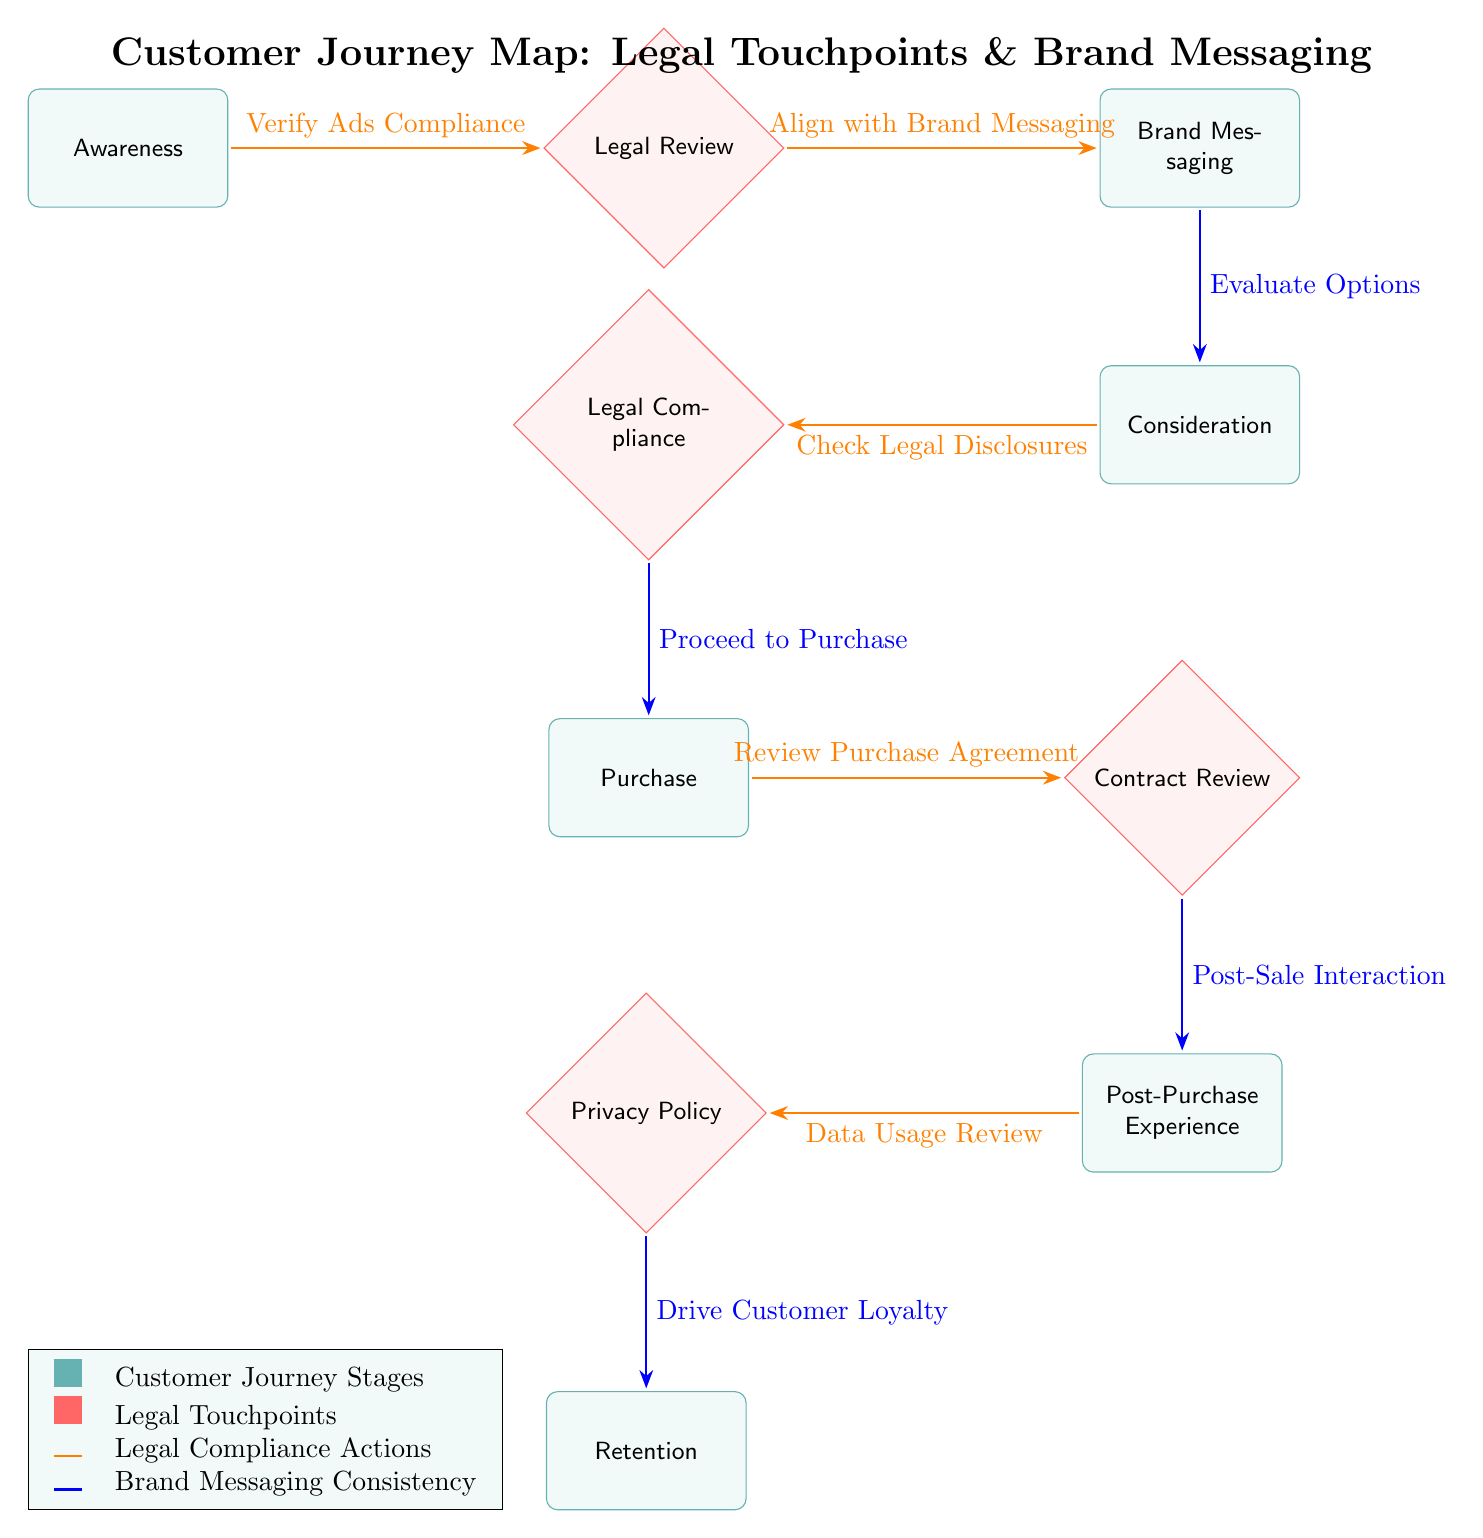What are the stages of the customer journey represented in the diagram? The diagram contains multiple nodes categorized as customer journey stages, including Awareness, Consideration, Purchase, Post-Purchase Experience, and Retention.
Answer: Awareness, Consideration, Purchase, Post-Purchase Experience, Retention How many legal touchpoints are indicated in the diagram? The diagram visually identifies three legal touchpoints represented by diamond-shaped nodes: Legal Review, Legal Compliance, and Contract Review, plus one additional node for Privacy Policy, totaling four legal touchpoints.
Answer: Four What action is associated with proceeding from the Purchase stage? The edge leading from the Purchase stage to the Contract Review legal touchpoint specifies the action "Review Purchase Agreement," highlighting the legal compliance necessary at this stage.
Answer: Review Purchase Agreement Which stage comes immediately after the Consideration stage? According to the flow of the diagram, the stage that follows Consideration is Purchase, which indicates the movement from evaluating options to actually making a purchase.
Answer: Purchase What is the legal action taken after the Post-Purchase Experience? The diagram indicates that after the Post-Purchase Experience, the legal action is related to data privacy, specifically noted as "Data Usage Review."
Answer: Data Usage Review What is the relationship between Legal Compliance and Purchase? The edge connecting Legal Compliance to the Purchase stage represents the action of "Proceed to Purchase," indicating that legal compliance directly influences the customer's decision to make a purchase.
Answer: Proceed to Purchase How many edges are displayed in the diagram? By counting the directional arrows that represent relationships between the nodes, there are a total of eight edges connecting various stages and legal touchpoints in the customer journey.
Answer: Eight What color represents the legal compliance actions in the diagram? The legal compliance actions are depicted by arrows colored in orange, differentiating them from customer journey stages and legal touchpoints based on coloration.
Answer: Orange Which two nodes are connected by the action "Align with Brand Messaging"? The action "Align with Brand Messaging" connects the Legal Review node to the Brand Messaging node, indicating that legal compliance must align with consistent brand messaging during the customer journey.
Answer: Legal Review and Brand Messaging 